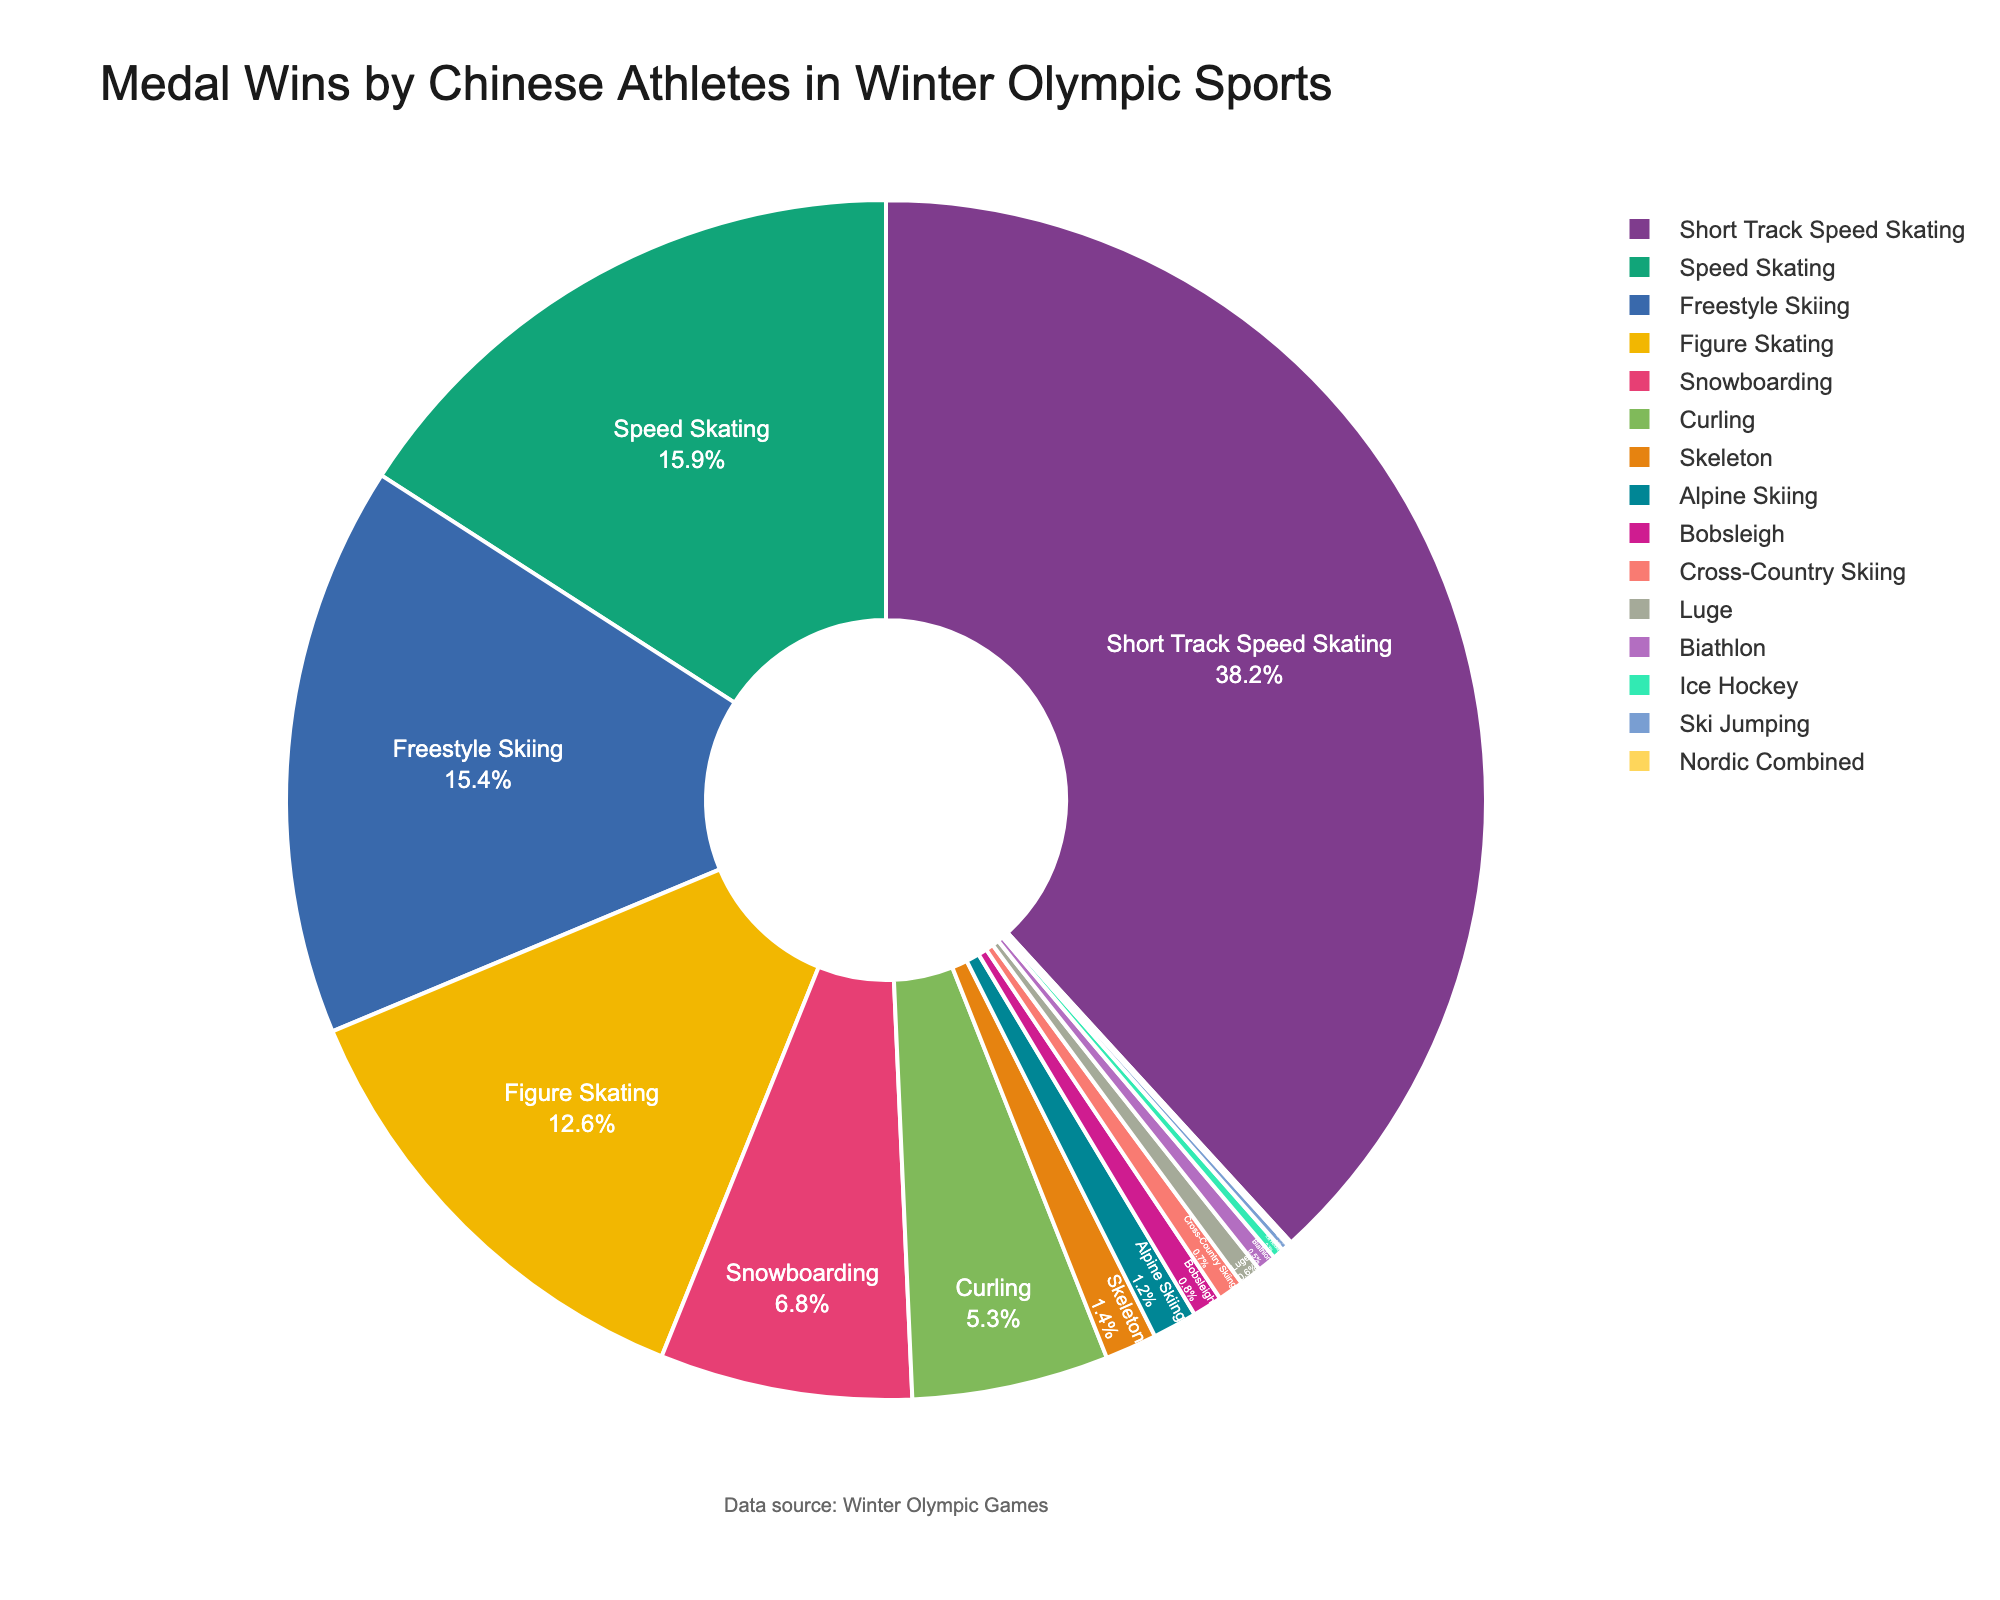What's the most successful winter sport for Chinese athletes in terms of medal wins? The largest portion of the pie chart represents the sport with the highest percentage of medal wins for Chinese athletes.
Answer: Short Track Speed Skating Which sport has a higher percentage of medal wins, Figure Skating or Speed Skating? By comparing the sizes of the slices for Figure Skating and Speed Skating, Speed Skating occupies a slightly larger portion of the chart.
Answer: Speed Skating What's the combined percentage of medal wins in Freestyle Skiing and Snowboarding? Add the percentages for Freestyle Skiing (15.4%) and Snowboarding (6.8%) to get the combined percentage.
Answer: 22.2% Which winter sports have a medal win percentage greater than 10% for Chinese athletes? By looking at the sections of the pie chart, the sports with slices larger than 10% are Figure Skating, Freestyle Skiing, Short Track Speed Skating, and Speed Skating.
Answer: Figure Skating, Freestyle Skiing, Short Track Speed Skating, Speed Skating How much larger is the medal win percentage for Short Track Speed Skating compared to Curling? Calculate the difference between the percentages for Short Track Speed Skating (38.2%) and Curling (5.3%).
Answer: 32.9% What is the total percentage of medal wins in the sports that fall under the category of skiing? Sum the percentages for Alpine Skiing (1.2%), Cross-Country Skiing (0.7%), Freestyle Skiing (15.4%), and Ski Jumping (0.2%).
Answer: 17.5% Is the percentage of medal wins in Bobsleigh higher than Skeleton? Compare the slices for Bobsleigh (0.8%) and Skeleton (1.4%) to see that Skeleton has a higher percentage.
Answer: No Which sport has a visually distinguishable smaller slice compared to Ice Hockey on the pie chart? By examining the chart, Nordic Combined with 0.1% has a smaller slice compared to Ice Hockey's 0.3%.
Answer: Nordic Combined What percentage of medal wins do all other sports apart from Short Track Speed Skating contribute to? Subtract the percentage of medal wins for Short Track Speed Skating (38.2%) from 100%.
Answer: 61.8% List the sports with percentages less than 1% and calculate their combined percentage. Identify sports with less than 1%: Biathlon (0.5%), Bobsleigh (0.8%), Cross-Country Skiing (0.7%), Ice Hockey (0.3%), Luge (0.6%), Nordic Combined (0.1%), and Ski Jumping (0.2%). Their combined percentage is the sum of these values.
Answer: 3.2% 